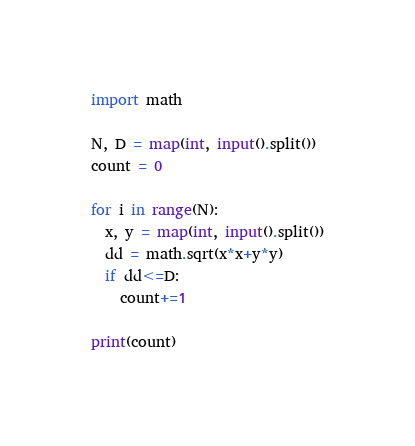<code> <loc_0><loc_0><loc_500><loc_500><_Python_>import math

N, D = map(int, input().split())
count = 0

for i in range(N):
  x, y = map(int, input().split())
  dd = math.sqrt(x*x+y*y)
  if dd<=D:
    count+=1

print(count)</code> 